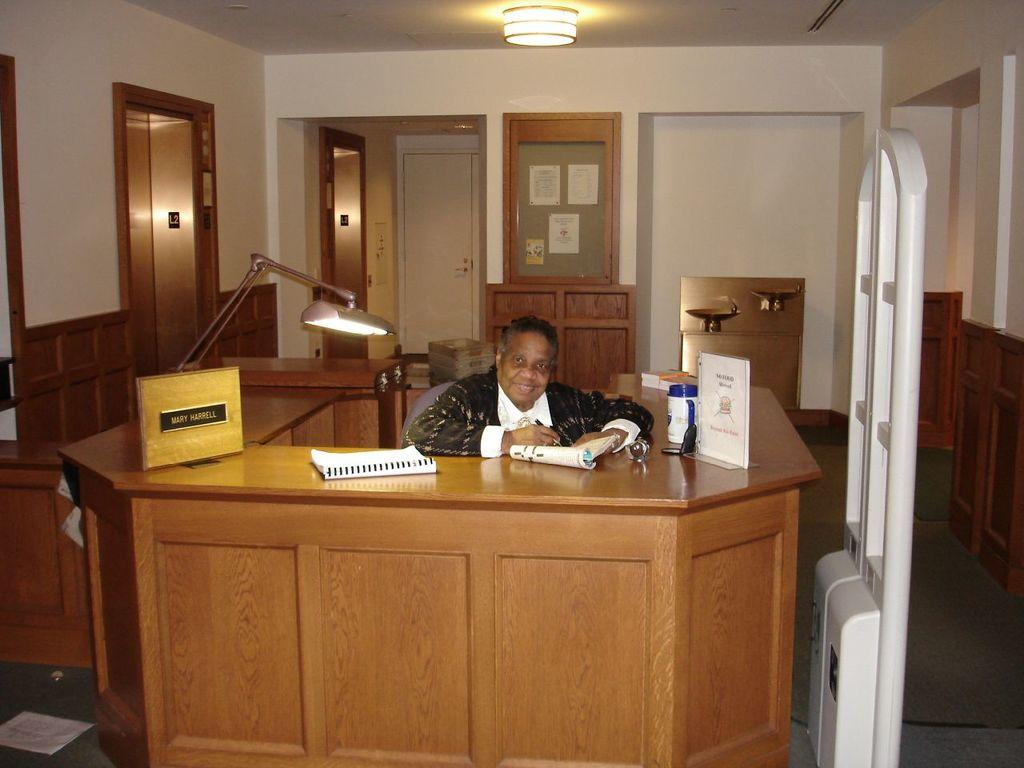What is the person in the image doing? The person is seated on a chair in the image. Can you describe the lighting in the image? There is a light in the image. What objects are on the table in the image? There are books and a bottle on the table in the image. What type of orange can be seen in the lunchroom during the rainstorm in the image? There is no orange, lunchroom, or rainstorm present in the image. 